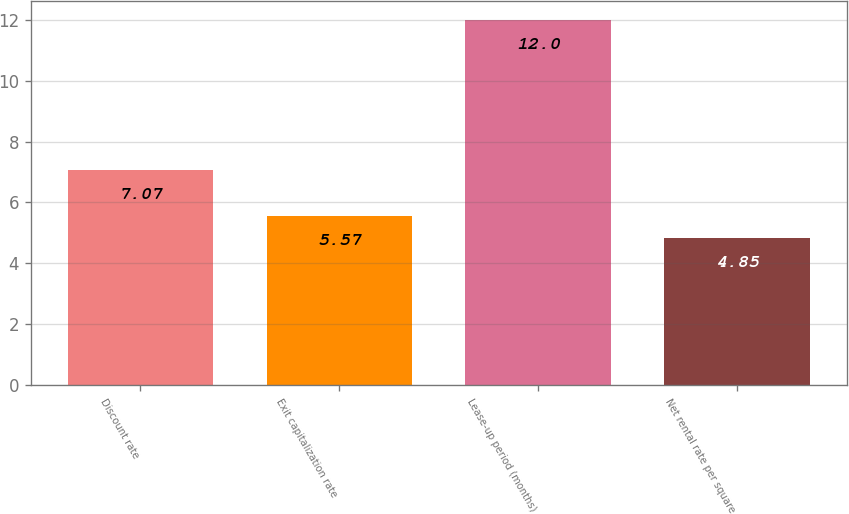Convert chart to OTSL. <chart><loc_0><loc_0><loc_500><loc_500><bar_chart><fcel>Discount rate<fcel>Exit capitalization rate<fcel>Lease-up period (months)<fcel>Net rental rate per square<nl><fcel>7.07<fcel>5.57<fcel>12<fcel>4.85<nl></chart> 